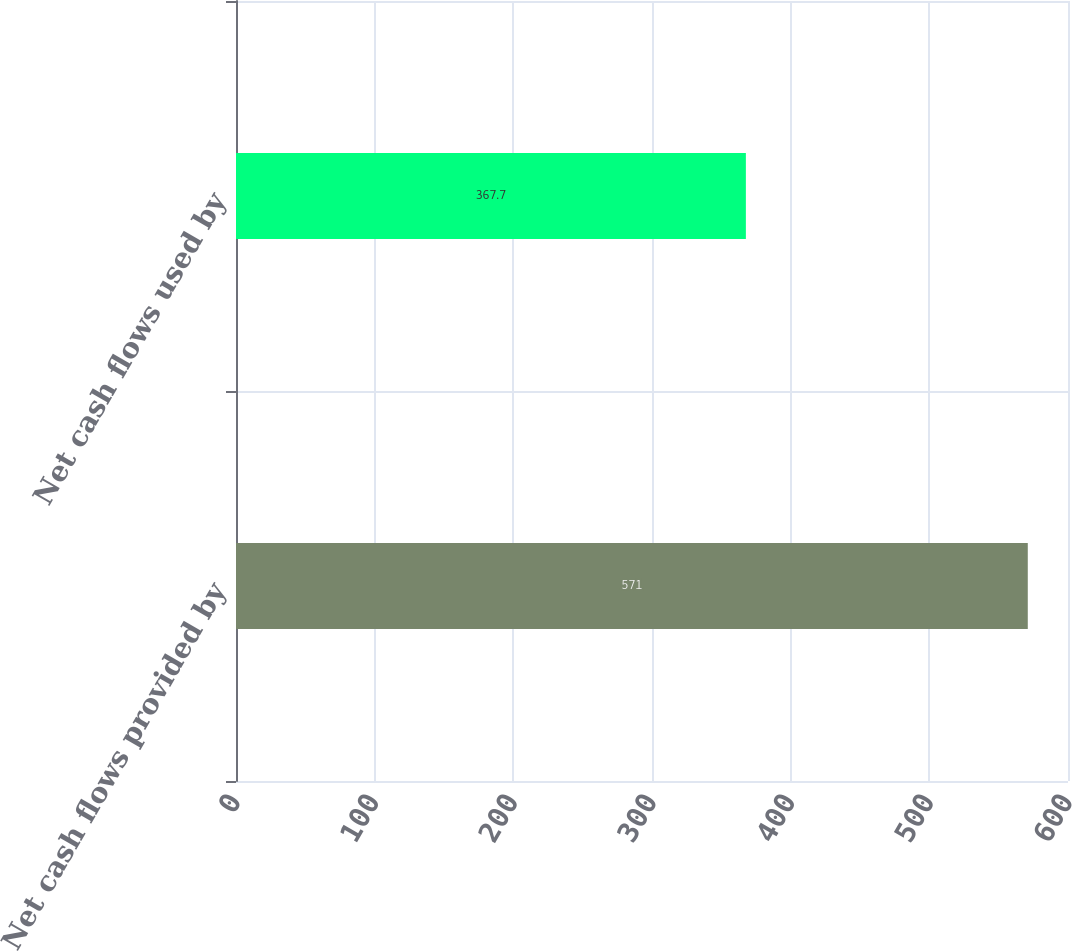Convert chart. <chart><loc_0><loc_0><loc_500><loc_500><bar_chart><fcel>Net cash flows provided by<fcel>Net cash flows used by<nl><fcel>571<fcel>367.7<nl></chart> 